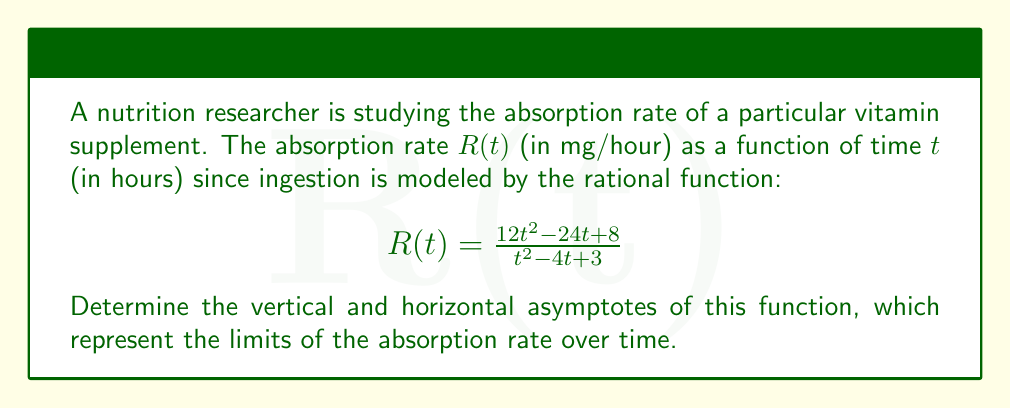Provide a solution to this math problem. To find the asymptotes of this rational function, we'll follow these steps:

1. Vertical Asymptotes:
   Vertical asymptotes occur where the denominator equals zero but the numerator doesn't.
   Set the denominator to zero:
   $t^2 - 4t + 3 = 0$
   Factor: $(t-1)(t-3) = 0$
   So, $t = 1$ or $t = 3$

   Check if the numerator is zero for these t values:
   For $t = 1$: $12(1)^2 - 24(1) + 8 = -4 \neq 0$
   For $t = 3$: $12(3)^2 - 24(3) + 8 = 44 \neq 0$

   Therefore, vertical asymptotes occur at $t = 1$ and $t = 3$.

2. Horizontal Asymptote:
   Compare the degrees of the numerator and denominator.
   Both have degree 2, so divide the leading coefficients:

   $$\lim_{t \to \infty} R(t) = \frac{12}{1} = 12$$

   The horizontal asymptote is $y = 12$.

These asymptotes represent the limits of the vitamin absorption rate. The vertical asymptotes indicate times when the absorption rate changes dramatically, while the horizontal asymptote shows the long-term absorption rate limit.
Answer: Vertical asymptotes: $t = 1, t = 3$; Horizontal asymptote: $y = 12$ 